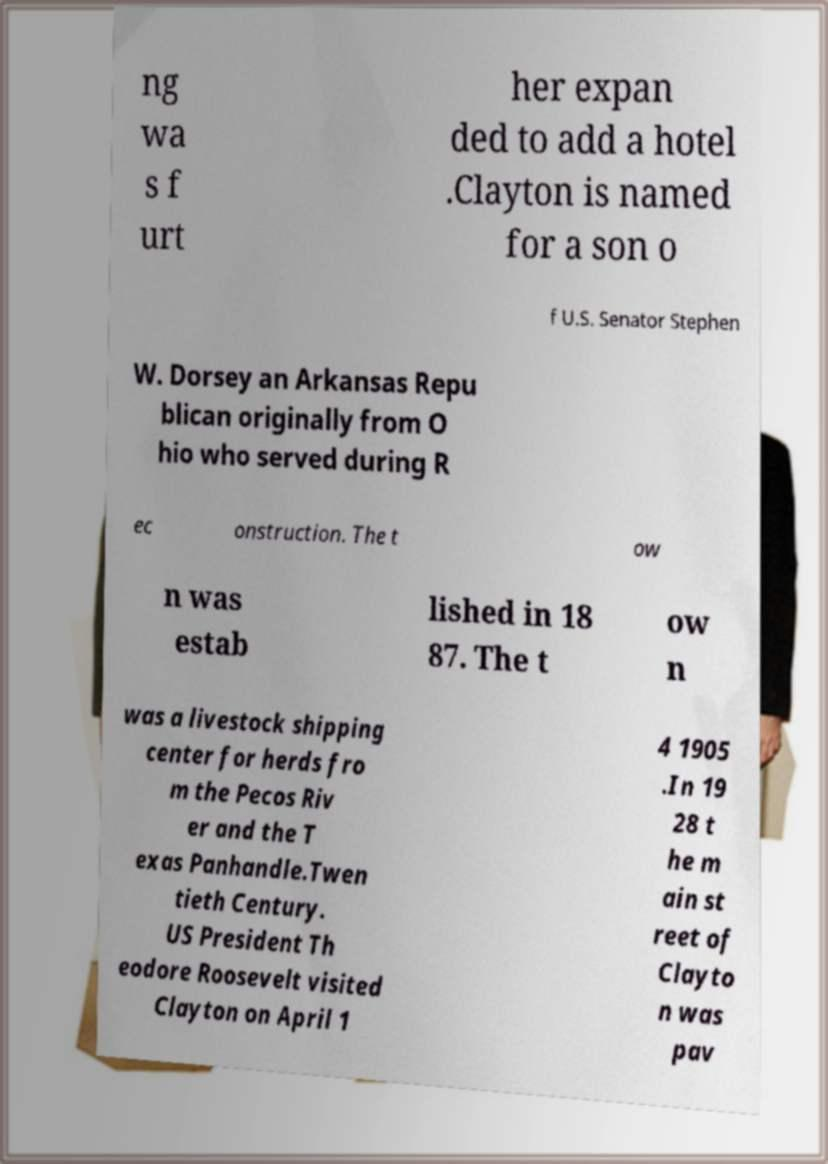Could you assist in decoding the text presented in this image and type it out clearly? ng wa s f urt her expan ded to add a hotel .Clayton is named for a son o f U.S. Senator Stephen W. Dorsey an Arkansas Repu blican originally from O hio who served during R ec onstruction. The t ow n was estab lished in 18 87. The t ow n was a livestock shipping center for herds fro m the Pecos Riv er and the T exas Panhandle.Twen tieth Century. US President Th eodore Roosevelt visited Clayton on April 1 4 1905 .In 19 28 t he m ain st reet of Clayto n was pav 